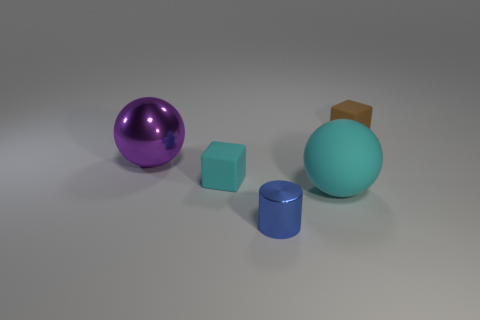Is the shiny sphere the same color as the tiny metallic object?
Ensure brevity in your answer.  No. Are there any cubes of the same color as the metallic cylinder?
Offer a very short reply. No. Is the number of blue things that are in front of the small blue metal thing greater than the number of tiny brown rubber cubes?
Give a very brief answer. No. There is a small blue object; does it have the same shape as the small rubber thing to the left of the big rubber object?
Your answer should be very brief. No. Are there any cyan rubber objects?
Provide a short and direct response. Yes. How many large objects are blue balls or brown matte objects?
Provide a short and direct response. 0. Are there more large cyan rubber things that are on the left side of the big cyan ball than blue objects behind the blue metallic object?
Make the answer very short. No. Is the material of the small blue thing the same as the large ball that is in front of the big purple object?
Provide a succinct answer. No. What is the color of the large matte sphere?
Provide a short and direct response. Cyan. What is the shape of the object that is behind the big purple metal object?
Your answer should be compact. Cube. 